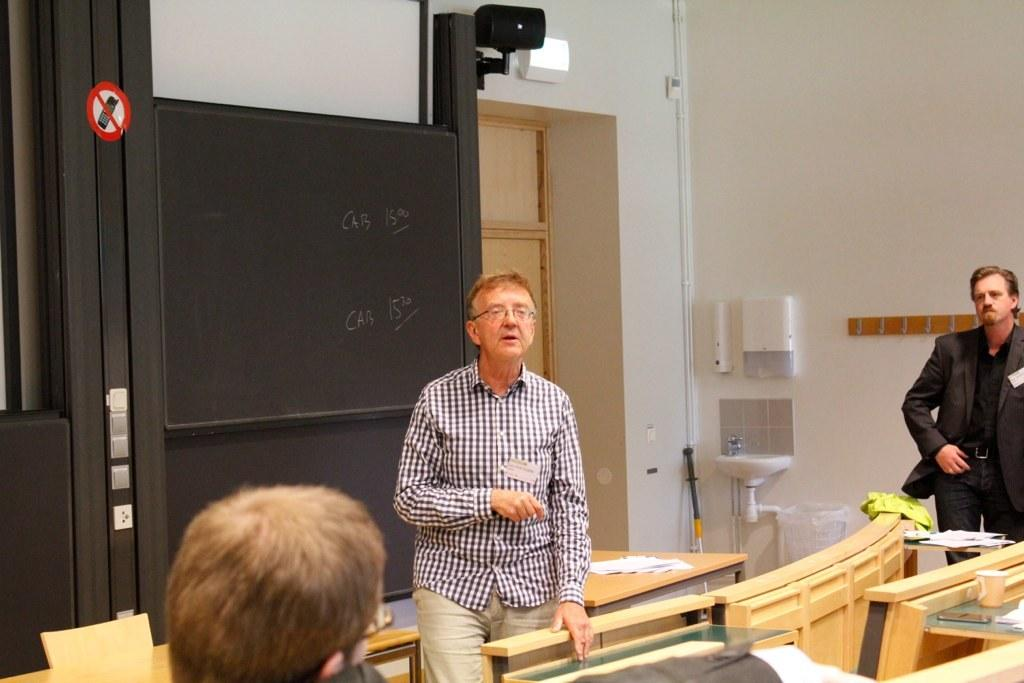How many people are present in the image? There are three people in the image. What is the person at the right corner wearing? The person at the right corner is wearing a suit. What is the position of the person at the center? The person at the center is standing. What can be seen on the wall in the image? There is a blackboard in the image. What architectural feature is visible in the image? There is a door in the image. What spark can be seen coming from the person at the left corner's pocket in the image? There is no person at the left corner in the image, and no spark or pocket is visible. 